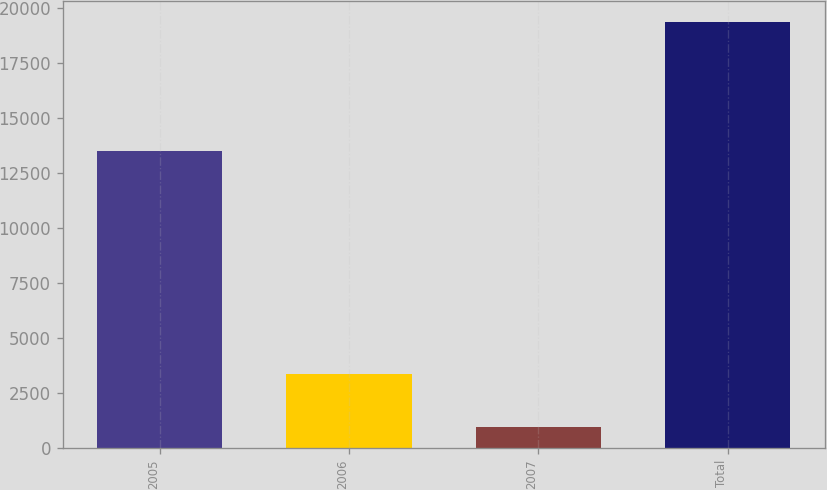<chart> <loc_0><loc_0><loc_500><loc_500><bar_chart><fcel>2005<fcel>2006<fcel>2007<fcel>Total<nl><fcel>13488<fcel>3369<fcel>927<fcel>19378<nl></chart> 